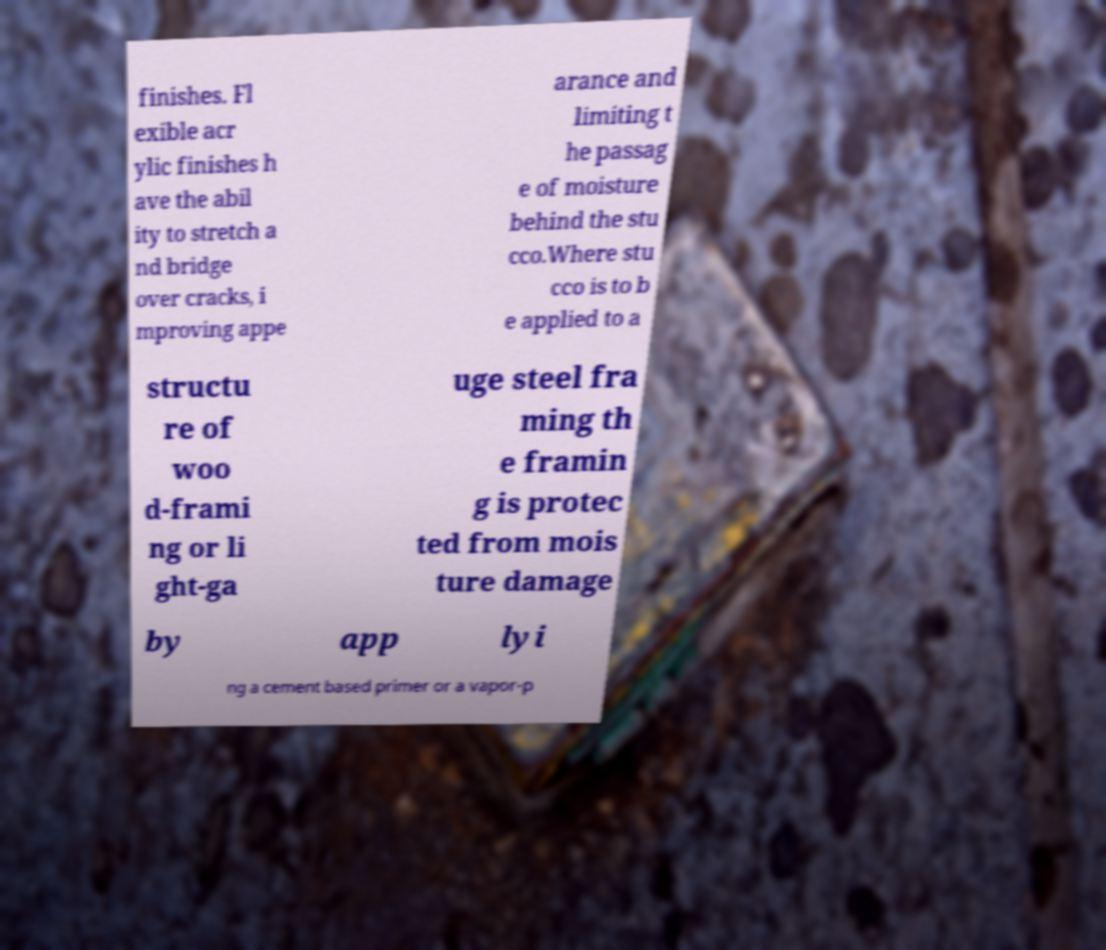For documentation purposes, I need the text within this image transcribed. Could you provide that? finishes. Fl exible acr ylic finishes h ave the abil ity to stretch a nd bridge over cracks, i mproving appe arance and limiting t he passag e of moisture behind the stu cco.Where stu cco is to b e applied to a structu re of woo d-frami ng or li ght-ga uge steel fra ming th e framin g is protec ted from mois ture damage by app lyi ng a cement based primer or a vapor-p 